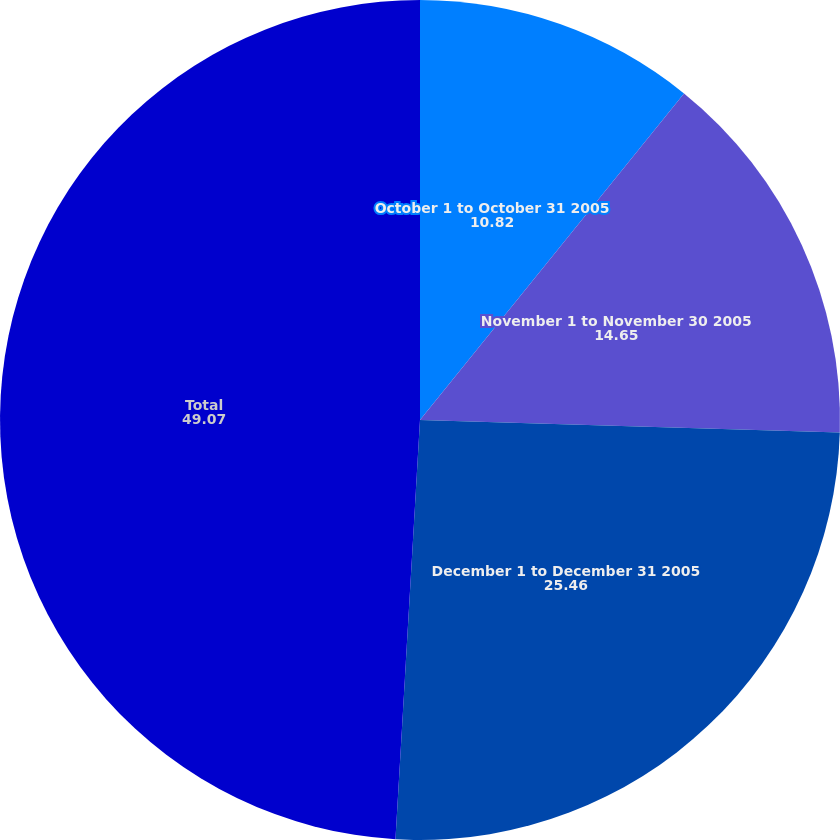Convert chart to OTSL. <chart><loc_0><loc_0><loc_500><loc_500><pie_chart><fcel>October 1 to October 31 2005<fcel>November 1 to November 30 2005<fcel>December 1 to December 31 2005<fcel>Total<nl><fcel>10.82%<fcel>14.65%<fcel>25.46%<fcel>49.07%<nl></chart> 